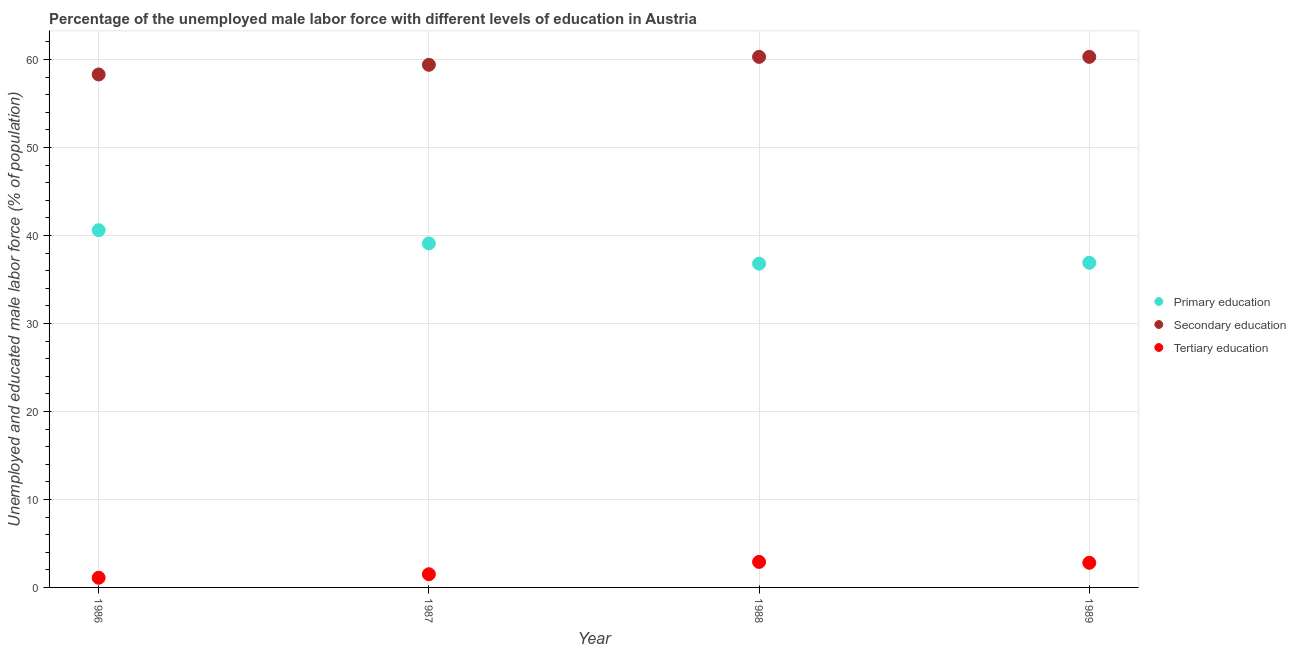How many different coloured dotlines are there?
Offer a very short reply. 3. Is the number of dotlines equal to the number of legend labels?
Provide a short and direct response. Yes. What is the percentage of male labor force who received primary education in 1988?
Your answer should be compact. 36.8. Across all years, what is the maximum percentage of male labor force who received tertiary education?
Ensure brevity in your answer.  2.9. Across all years, what is the minimum percentage of male labor force who received primary education?
Offer a very short reply. 36.8. In which year was the percentage of male labor force who received primary education maximum?
Offer a terse response. 1986. What is the total percentage of male labor force who received secondary education in the graph?
Offer a very short reply. 238.3. What is the difference between the percentage of male labor force who received primary education in 1986 and that in 1988?
Make the answer very short. 3.8. What is the difference between the percentage of male labor force who received secondary education in 1987 and the percentage of male labor force who received tertiary education in 1986?
Your answer should be compact. 58.3. What is the average percentage of male labor force who received primary education per year?
Give a very brief answer. 38.35. In the year 1989, what is the difference between the percentage of male labor force who received primary education and percentage of male labor force who received tertiary education?
Make the answer very short. 34.1. In how many years, is the percentage of male labor force who received secondary education greater than 46 %?
Make the answer very short. 4. What is the ratio of the percentage of male labor force who received primary education in 1988 to that in 1989?
Your answer should be compact. 1. Is the difference between the percentage of male labor force who received primary education in 1986 and 1987 greater than the difference between the percentage of male labor force who received tertiary education in 1986 and 1987?
Provide a succinct answer. Yes. What is the difference between the highest and the second highest percentage of male labor force who received tertiary education?
Provide a short and direct response. 0.1. What is the difference between the highest and the lowest percentage of male labor force who received secondary education?
Your answer should be very brief. 2. Does the percentage of male labor force who received tertiary education monotonically increase over the years?
Provide a succinct answer. No. Is the percentage of male labor force who received tertiary education strictly greater than the percentage of male labor force who received primary education over the years?
Your answer should be compact. No. How many dotlines are there?
Make the answer very short. 3. Are the values on the major ticks of Y-axis written in scientific E-notation?
Your answer should be compact. No. Where does the legend appear in the graph?
Provide a short and direct response. Center right. What is the title of the graph?
Your response must be concise. Percentage of the unemployed male labor force with different levels of education in Austria. What is the label or title of the Y-axis?
Provide a succinct answer. Unemployed and educated male labor force (% of population). What is the Unemployed and educated male labor force (% of population) of Primary education in 1986?
Offer a very short reply. 40.6. What is the Unemployed and educated male labor force (% of population) in Secondary education in 1986?
Your answer should be very brief. 58.3. What is the Unemployed and educated male labor force (% of population) in Tertiary education in 1986?
Offer a very short reply. 1.1. What is the Unemployed and educated male labor force (% of population) of Primary education in 1987?
Your answer should be compact. 39.1. What is the Unemployed and educated male labor force (% of population) in Secondary education in 1987?
Offer a very short reply. 59.4. What is the Unemployed and educated male labor force (% of population) in Primary education in 1988?
Your response must be concise. 36.8. What is the Unemployed and educated male labor force (% of population) of Secondary education in 1988?
Your response must be concise. 60.3. What is the Unemployed and educated male labor force (% of population) in Tertiary education in 1988?
Provide a succinct answer. 2.9. What is the Unemployed and educated male labor force (% of population) in Primary education in 1989?
Make the answer very short. 36.9. What is the Unemployed and educated male labor force (% of population) of Secondary education in 1989?
Offer a very short reply. 60.3. What is the Unemployed and educated male labor force (% of population) of Tertiary education in 1989?
Offer a terse response. 2.8. Across all years, what is the maximum Unemployed and educated male labor force (% of population) of Primary education?
Provide a succinct answer. 40.6. Across all years, what is the maximum Unemployed and educated male labor force (% of population) in Secondary education?
Give a very brief answer. 60.3. Across all years, what is the maximum Unemployed and educated male labor force (% of population) of Tertiary education?
Offer a very short reply. 2.9. Across all years, what is the minimum Unemployed and educated male labor force (% of population) of Primary education?
Make the answer very short. 36.8. Across all years, what is the minimum Unemployed and educated male labor force (% of population) of Secondary education?
Your answer should be very brief. 58.3. Across all years, what is the minimum Unemployed and educated male labor force (% of population) of Tertiary education?
Provide a succinct answer. 1.1. What is the total Unemployed and educated male labor force (% of population) of Primary education in the graph?
Provide a succinct answer. 153.4. What is the total Unemployed and educated male labor force (% of population) of Secondary education in the graph?
Offer a terse response. 238.3. What is the difference between the Unemployed and educated male labor force (% of population) of Primary education in 1986 and that in 1988?
Your answer should be very brief. 3.8. What is the difference between the Unemployed and educated male labor force (% of population) of Secondary education in 1986 and that in 1988?
Provide a short and direct response. -2. What is the difference between the Unemployed and educated male labor force (% of population) of Tertiary education in 1986 and that in 1988?
Your answer should be very brief. -1.8. What is the difference between the Unemployed and educated male labor force (% of population) in Tertiary education in 1986 and that in 1989?
Provide a short and direct response. -1.7. What is the difference between the Unemployed and educated male labor force (% of population) in Primary education in 1987 and that in 1988?
Give a very brief answer. 2.3. What is the difference between the Unemployed and educated male labor force (% of population) of Primary education in 1987 and that in 1989?
Give a very brief answer. 2.2. What is the difference between the Unemployed and educated male labor force (% of population) in Primary education in 1988 and that in 1989?
Your answer should be very brief. -0.1. What is the difference between the Unemployed and educated male labor force (% of population) in Secondary education in 1988 and that in 1989?
Your response must be concise. 0. What is the difference between the Unemployed and educated male labor force (% of population) in Primary education in 1986 and the Unemployed and educated male labor force (% of population) in Secondary education in 1987?
Your answer should be very brief. -18.8. What is the difference between the Unemployed and educated male labor force (% of population) of Primary education in 1986 and the Unemployed and educated male labor force (% of population) of Tertiary education in 1987?
Make the answer very short. 39.1. What is the difference between the Unemployed and educated male labor force (% of population) of Secondary education in 1986 and the Unemployed and educated male labor force (% of population) of Tertiary education in 1987?
Your answer should be compact. 56.8. What is the difference between the Unemployed and educated male labor force (% of population) in Primary education in 1986 and the Unemployed and educated male labor force (% of population) in Secondary education in 1988?
Your response must be concise. -19.7. What is the difference between the Unemployed and educated male labor force (% of population) in Primary education in 1986 and the Unemployed and educated male labor force (% of population) in Tertiary education in 1988?
Keep it short and to the point. 37.7. What is the difference between the Unemployed and educated male labor force (% of population) of Secondary education in 1986 and the Unemployed and educated male labor force (% of population) of Tertiary education in 1988?
Offer a terse response. 55.4. What is the difference between the Unemployed and educated male labor force (% of population) in Primary education in 1986 and the Unemployed and educated male labor force (% of population) in Secondary education in 1989?
Provide a succinct answer. -19.7. What is the difference between the Unemployed and educated male labor force (% of population) in Primary education in 1986 and the Unemployed and educated male labor force (% of population) in Tertiary education in 1989?
Offer a very short reply. 37.8. What is the difference between the Unemployed and educated male labor force (% of population) of Secondary education in 1986 and the Unemployed and educated male labor force (% of population) of Tertiary education in 1989?
Provide a succinct answer. 55.5. What is the difference between the Unemployed and educated male labor force (% of population) of Primary education in 1987 and the Unemployed and educated male labor force (% of population) of Secondary education in 1988?
Your answer should be very brief. -21.2. What is the difference between the Unemployed and educated male labor force (% of population) of Primary education in 1987 and the Unemployed and educated male labor force (% of population) of Tertiary education in 1988?
Offer a very short reply. 36.2. What is the difference between the Unemployed and educated male labor force (% of population) in Secondary education in 1987 and the Unemployed and educated male labor force (% of population) in Tertiary education in 1988?
Offer a very short reply. 56.5. What is the difference between the Unemployed and educated male labor force (% of population) in Primary education in 1987 and the Unemployed and educated male labor force (% of population) in Secondary education in 1989?
Your answer should be very brief. -21.2. What is the difference between the Unemployed and educated male labor force (% of population) of Primary education in 1987 and the Unemployed and educated male labor force (% of population) of Tertiary education in 1989?
Your response must be concise. 36.3. What is the difference between the Unemployed and educated male labor force (% of population) in Secondary education in 1987 and the Unemployed and educated male labor force (% of population) in Tertiary education in 1989?
Make the answer very short. 56.6. What is the difference between the Unemployed and educated male labor force (% of population) of Primary education in 1988 and the Unemployed and educated male labor force (% of population) of Secondary education in 1989?
Your answer should be very brief. -23.5. What is the difference between the Unemployed and educated male labor force (% of population) of Secondary education in 1988 and the Unemployed and educated male labor force (% of population) of Tertiary education in 1989?
Your answer should be very brief. 57.5. What is the average Unemployed and educated male labor force (% of population) of Primary education per year?
Keep it short and to the point. 38.35. What is the average Unemployed and educated male labor force (% of population) in Secondary education per year?
Your answer should be compact. 59.58. What is the average Unemployed and educated male labor force (% of population) of Tertiary education per year?
Offer a terse response. 2.08. In the year 1986, what is the difference between the Unemployed and educated male labor force (% of population) of Primary education and Unemployed and educated male labor force (% of population) of Secondary education?
Give a very brief answer. -17.7. In the year 1986, what is the difference between the Unemployed and educated male labor force (% of population) of Primary education and Unemployed and educated male labor force (% of population) of Tertiary education?
Your answer should be very brief. 39.5. In the year 1986, what is the difference between the Unemployed and educated male labor force (% of population) of Secondary education and Unemployed and educated male labor force (% of population) of Tertiary education?
Offer a terse response. 57.2. In the year 1987, what is the difference between the Unemployed and educated male labor force (% of population) of Primary education and Unemployed and educated male labor force (% of population) of Secondary education?
Your answer should be very brief. -20.3. In the year 1987, what is the difference between the Unemployed and educated male labor force (% of population) of Primary education and Unemployed and educated male labor force (% of population) of Tertiary education?
Give a very brief answer. 37.6. In the year 1987, what is the difference between the Unemployed and educated male labor force (% of population) in Secondary education and Unemployed and educated male labor force (% of population) in Tertiary education?
Your response must be concise. 57.9. In the year 1988, what is the difference between the Unemployed and educated male labor force (% of population) of Primary education and Unemployed and educated male labor force (% of population) of Secondary education?
Your answer should be very brief. -23.5. In the year 1988, what is the difference between the Unemployed and educated male labor force (% of population) of Primary education and Unemployed and educated male labor force (% of population) of Tertiary education?
Your answer should be compact. 33.9. In the year 1988, what is the difference between the Unemployed and educated male labor force (% of population) of Secondary education and Unemployed and educated male labor force (% of population) of Tertiary education?
Your answer should be compact. 57.4. In the year 1989, what is the difference between the Unemployed and educated male labor force (% of population) in Primary education and Unemployed and educated male labor force (% of population) in Secondary education?
Make the answer very short. -23.4. In the year 1989, what is the difference between the Unemployed and educated male labor force (% of population) in Primary education and Unemployed and educated male labor force (% of population) in Tertiary education?
Offer a very short reply. 34.1. In the year 1989, what is the difference between the Unemployed and educated male labor force (% of population) in Secondary education and Unemployed and educated male labor force (% of population) in Tertiary education?
Offer a very short reply. 57.5. What is the ratio of the Unemployed and educated male labor force (% of population) of Primary education in 1986 to that in 1987?
Keep it short and to the point. 1.04. What is the ratio of the Unemployed and educated male labor force (% of population) in Secondary education in 1986 to that in 1987?
Give a very brief answer. 0.98. What is the ratio of the Unemployed and educated male labor force (% of population) in Tertiary education in 1986 to that in 1987?
Make the answer very short. 0.73. What is the ratio of the Unemployed and educated male labor force (% of population) of Primary education in 1986 to that in 1988?
Your answer should be very brief. 1.1. What is the ratio of the Unemployed and educated male labor force (% of population) in Secondary education in 1986 to that in 1988?
Give a very brief answer. 0.97. What is the ratio of the Unemployed and educated male labor force (% of population) of Tertiary education in 1986 to that in 1988?
Provide a succinct answer. 0.38. What is the ratio of the Unemployed and educated male labor force (% of population) of Primary education in 1986 to that in 1989?
Offer a very short reply. 1.1. What is the ratio of the Unemployed and educated male labor force (% of population) in Secondary education in 1986 to that in 1989?
Offer a very short reply. 0.97. What is the ratio of the Unemployed and educated male labor force (% of population) in Tertiary education in 1986 to that in 1989?
Offer a terse response. 0.39. What is the ratio of the Unemployed and educated male labor force (% of population) of Primary education in 1987 to that in 1988?
Your answer should be very brief. 1.06. What is the ratio of the Unemployed and educated male labor force (% of population) of Secondary education in 1987 to that in 1988?
Make the answer very short. 0.99. What is the ratio of the Unemployed and educated male labor force (% of population) of Tertiary education in 1987 to that in 1988?
Your answer should be compact. 0.52. What is the ratio of the Unemployed and educated male labor force (% of population) of Primary education in 1987 to that in 1989?
Make the answer very short. 1.06. What is the ratio of the Unemployed and educated male labor force (% of population) in Secondary education in 1987 to that in 1989?
Offer a very short reply. 0.99. What is the ratio of the Unemployed and educated male labor force (% of population) of Tertiary education in 1987 to that in 1989?
Your response must be concise. 0.54. What is the ratio of the Unemployed and educated male labor force (% of population) of Primary education in 1988 to that in 1989?
Your answer should be very brief. 1. What is the ratio of the Unemployed and educated male labor force (% of population) of Tertiary education in 1988 to that in 1989?
Ensure brevity in your answer.  1.04. What is the difference between the highest and the second highest Unemployed and educated male labor force (% of population) in Primary education?
Your response must be concise. 1.5. What is the difference between the highest and the lowest Unemployed and educated male labor force (% of population) in Primary education?
Your response must be concise. 3.8. What is the difference between the highest and the lowest Unemployed and educated male labor force (% of population) in Secondary education?
Ensure brevity in your answer.  2. What is the difference between the highest and the lowest Unemployed and educated male labor force (% of population) in Tertiary education?
Your response must be concise. 1.8. 